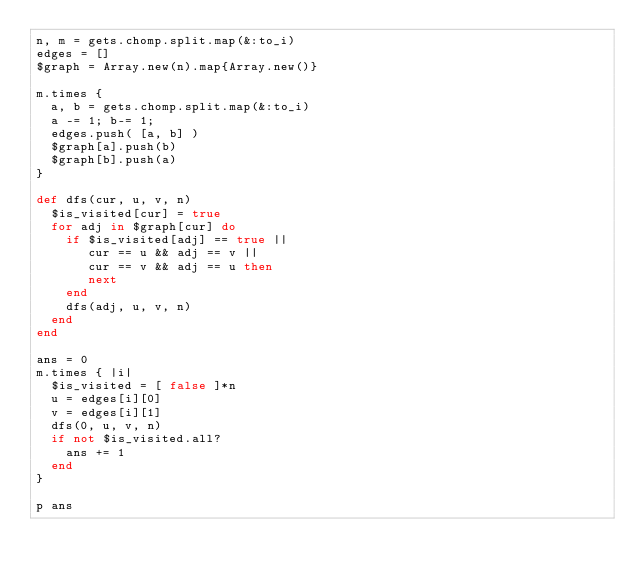Convert code to text. <code><loc_0><loc_0><loc_500><loc_500><_Ruby_>n, m = gets.chomp.split.map(&:to_i)
edges = []
$graph = Array.new(n).map{Array.new()}

m.times {
  a, b = gets.chomp.split.map(&:to_i)
  a -= 1; b-= 1;
  edges.push( [a, b] )
  $graph[a].push(b)
  $graph[b].push(a)
}

def dfs(cur, u, v, n)
  $is_visited[cur] = true
  for adj in $graph[cur] do
    if $is_visited[adj] == true ||
       cur == u && adj == v ||
       cur == v && adj == u then
       next
    end
    dfs(adj, u, v, n)
  end
end

ans = 0
m.times { |i|
  $is_visited = [ false ]*n
  u = edges[i][0]
  v = edges[i][1]
  dfs(0, u, v, n)
  if not $is_visited.all?
    ans += 1
  end
}

p ans
</code> 